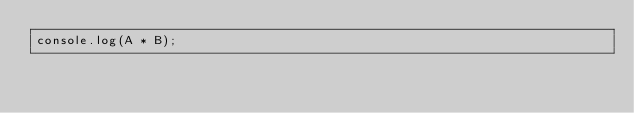<code> <loc_0><loc_0><loc_500><loc_500><_JavaScript_>console.log(A * B);</code> 